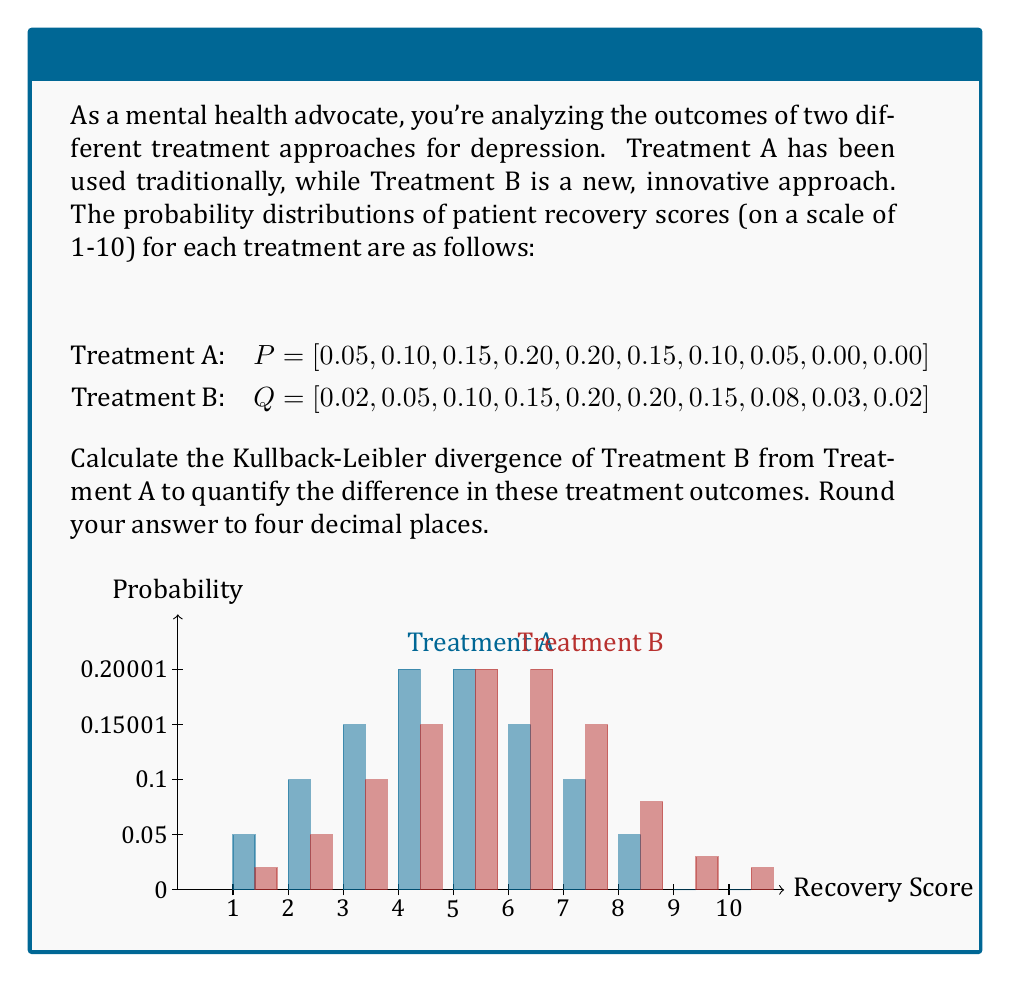Teach me how to tackle this problem. To calculate the Kullback-Leibler divergence of Treatment B from Treatment A, we'll use the formula:

$$D_{KL}(P||Q) = \sum_{i} P(i) \log\left(\frac{P(i)}{Q(i)}\right)$$

Let's go through this step-by-step:

1) First, we need to calculate $\frac{P(i)}{Q(i)}$ for each i:
   
   i=1: 0.05 / 0.02 = 2.5
   i=2: 0.10 / 0.05 = 2.0
   i=3: 0.15 / 0.10 = 1.5
   i=4: 0.20 / 0.15 = 1.3333
   i=5: 0.20 / 0.20 = 1.0
   i=6: 0.15 / 0.20 = 0.75
   i=7: 0.10 / 0.15 = 0.6667
   i=8: 0.05 / 0.08 = 0.625
   i=9: 0.00 / 0.03 = 0 (we'll treat this as 0 in the calculation)
   i=10: 0.00 / 0.02 = 0 (we'll treat this as 0 in the calculation)

2) Now, we calculate $P(i) \log\left(\frac{P(i)}{Q(i)}\right)$ for each i:
   
   i=1: 0.05 * log(2.5) = 0.0456
   i=2: 0.10 * log(2.0) = 0.0693
   i=3: 0.15 * log(1.5) = 0.0608
   i=4: 0.20 * log(1.3333) = 0.0577
   i=5: 0.20 * log(1.0) = 0
   i=6: 0.15 * log(0.75) = -0.0432
   i=7: 0.10 * log(0.6667) = -0.0406
   i=8: 0.05 * log(0.625) = -0.0236
   i=9: 0 * log(0) = 0 (by convention, 0 * log(0) = 0)
   i=10: 0 * log(0) = 0

3) Sum up all these values:

   0.0456 + 0.0693 + 0.0608 + 0.0577 + 0 + (-0.0432) + (-0.0406) + (-0.0236) + 0 + 0 = 0.1260

4) Rounding to four decimal places: 0.1260

This value represents the relative entropy of Treatment B with respect to Treatment A, indicating how much information is lost when Treatment B is used to approximate Treatment A.
Answer: 0.1260 